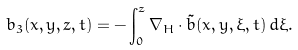Convert formula to latex. <formula><loc_0><loc_0><loc_500><loc_500>b _ { 3 } ( x , y , z , t ) = - \int _ { 0 } ^ { z } \nabla _ { H } \cdot \tilde { b } ( x , y , \xi , t ) \, d \xi .</formula> 